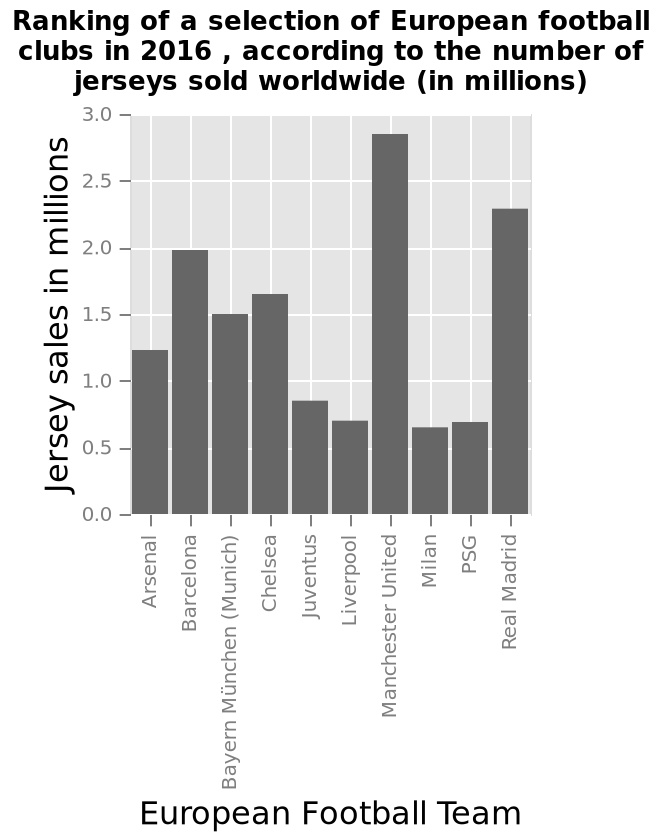<image>
please describe the details of the chart Ranking of a selection of European football clubs in 2016 , according to the number of jerseys sold worldwide (in millions) is a bar chart. European Football Team is shown on the x-axis. Along the y-axis, Jersey sales in millions is drawn as a linear scale of range 0.0 to 3.0. What does the bar chart rank the European football clubs according to? The bar chart ranks the European football clubs according to the number of jerseys sold worldwide. Is the ranking of a selection of European football clubs in 2016 according to the number of jerseys sold worldwide (in millions) shown as a pie chart? No.Ranking of a selection of European football clubs in 2016 , according to the number of jerseys sold worldwide (in millions) is a bar chart. European Football Team is shown on the x-axis. Along the y-axis, Jersey sales in millions is drawn as a linear scale of range 0.0 to 3.0. 